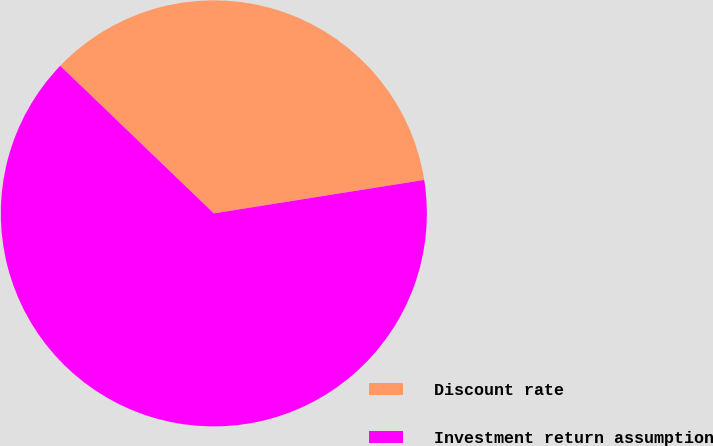<chart> <loc_0><loc_0><loc_500><loc_500><pie_chart><fcel>Discount rate<fcel>Investment return assumption<nl><fcel>35.31%<fcel>64.69%<nl></chart> 